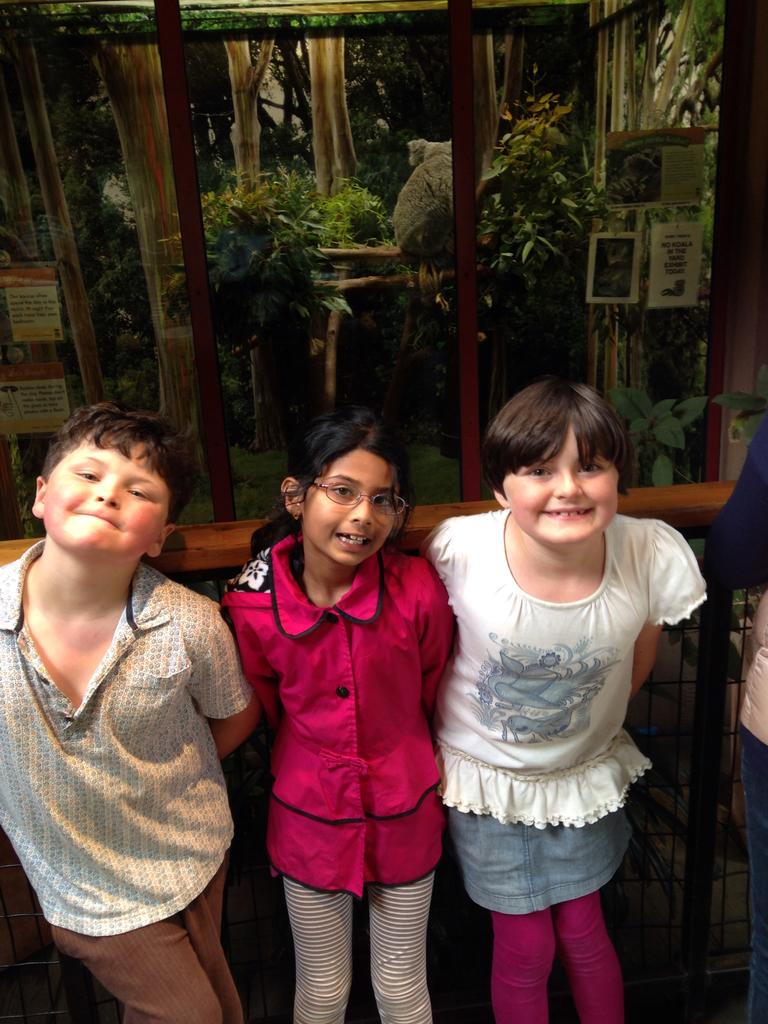What is the main subject in the center of the image? There are kids in the center of the image. What can be seen in the background of the image? There is a glass window, plants, trees, and stickers in the background of the image. What type of mint is being used in the agreement between the men in the image? There are no men or agreement present in the image, and therefore no mint is involved. 